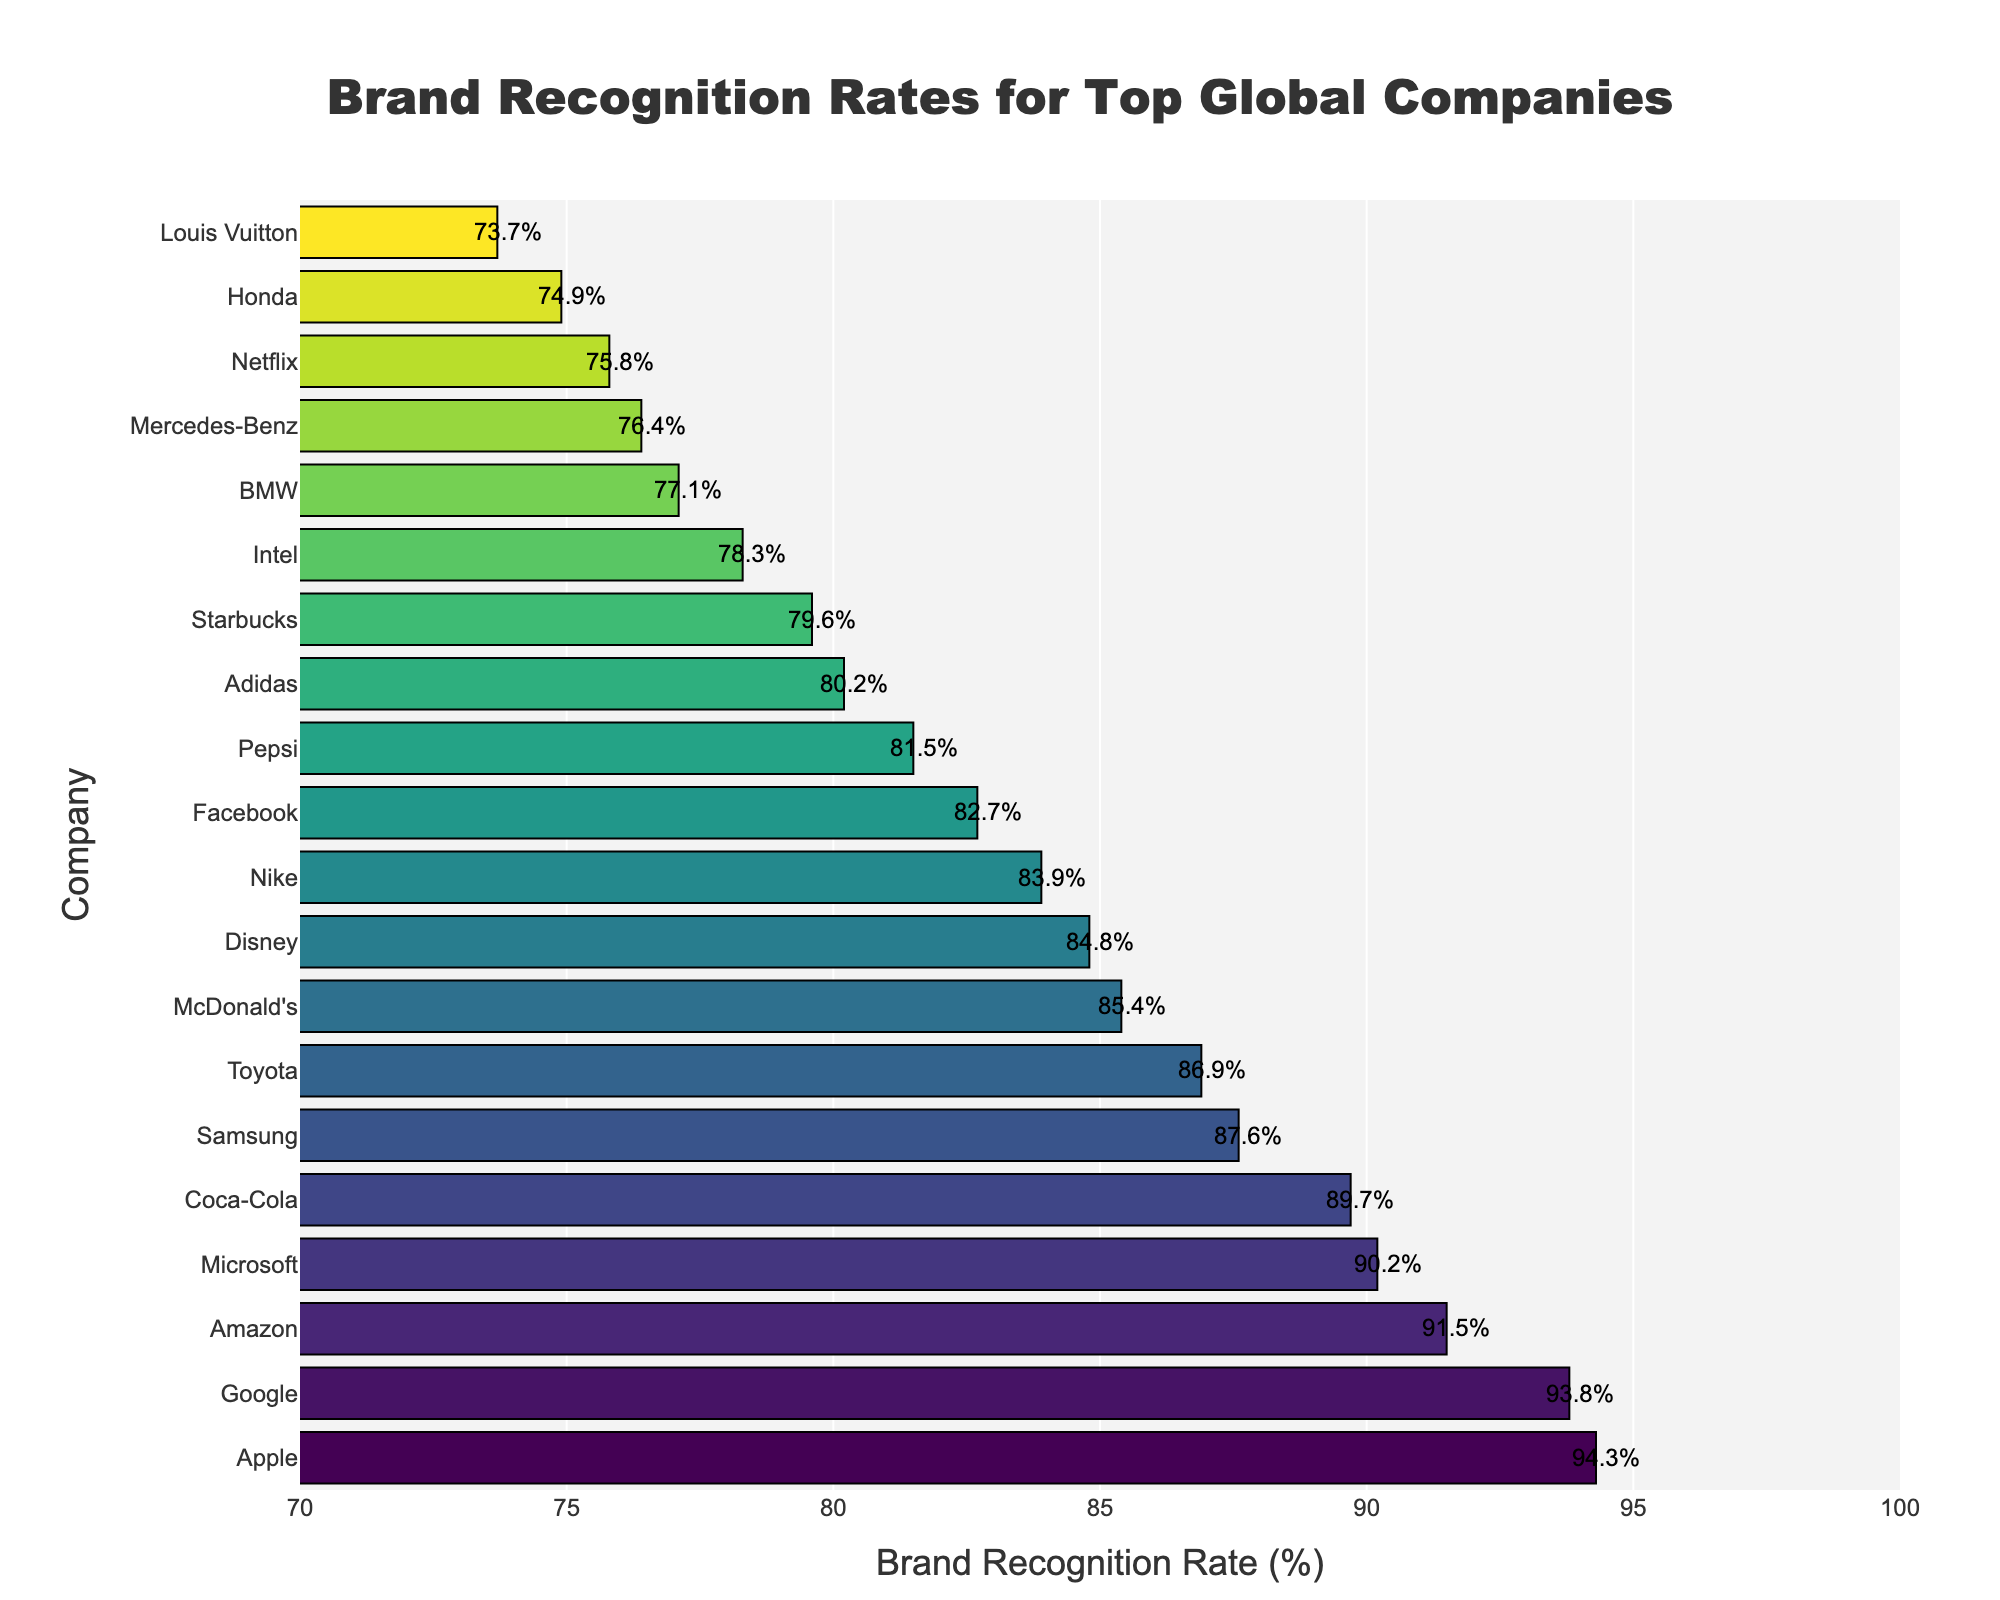What's the brand recognition rate of the second highest company? The second highest company on the horizontal bar chart is Google. The text label along the bar indicates a brand recognition rate of 93.8%.
Answer: 93.8% Which company has the lowest brand recognition rate? By looking at the shortest bar in the chart and its corresponding company name, we see that the company with the lowest brand recognition rate is Louis Vuitton.
Answer: Louis Vuitton How much higher is Apple's brand recognition rate compared to Disney's? Apple's brand recognition rate is 94.3%, and Disney's rate is 84.8%. The difference between them is calculated as 94.3% - 84.8% = 9.5%.
Answer: 9.5% Which companies have brand recognition rates greater than 90%? Observing the bars that extend beyond the 90% mark on the x-axis, we see that Apple, Google, Amazon, and Microsoft all have brand recognition rates greater than 90%.
Answer: Apple, Google, Amazon, Microsoft How many companies have a brand recognition rate between 80% and 85%? We look at the bars that fall between the 80% and 85% marks on the x-axis. The companies in this range are Nike, Facebook, and Pepsi. There are 3 companies in total.
Answer: 3 What is the average brand recognition rate of Amazon and Microsoft? The brand recognition rates are 91.5% for Amazon and 90.2% for Microsoft. The average is calculated as (91.5 + 90.2) / 2 = 90.85%.
Answer: 90.85% Which company is ranked fifth in brand recognition rate? Sorting the bars by length from top to bottom, the fifth company is Coca-Cola with a brand recognition rate of 89.7%.
Answer: Coca-Cola What is the total brand recognition rate of the top three companies? The recognition rates for the top three companies (Apple, Google, and Amazon) are 94.3%, 93.8%, and 91.5% respectively. Adding them together, we get 94.3 + 93.8 + 91.5 = 279.6%.
Answer: 279.6% Does Toyota have a higher brand recognition rate than Samsung? Comparing the lengths of the bars for Toyota and Samsung, Toyota's rate is 86.9%, and Samsung's rate is 87.6%. Therefore, Toyota's rate is lower.
Answer: No What is the median brand recognition rate of the listed companies? To find the median, we list the recognition rates in order and find the middle value. The listed rates from highest to lowest are: 94.3, 93.8, 91.5, 90.2, 89.7, 87.6, 86.9, 85.4, 84.8, 83.9, 82.7, 81.5, 80.2, 79.6, 78.3, 77.1, 76.4, 75.8, 74.9, 73.7. With 20 values, the median is the average of the 10th and 11th values. These values are 83.9 and 82.7, so the median is (83.9 + 82.7) / 2 = 83.3%.
Answer: 83.3% 